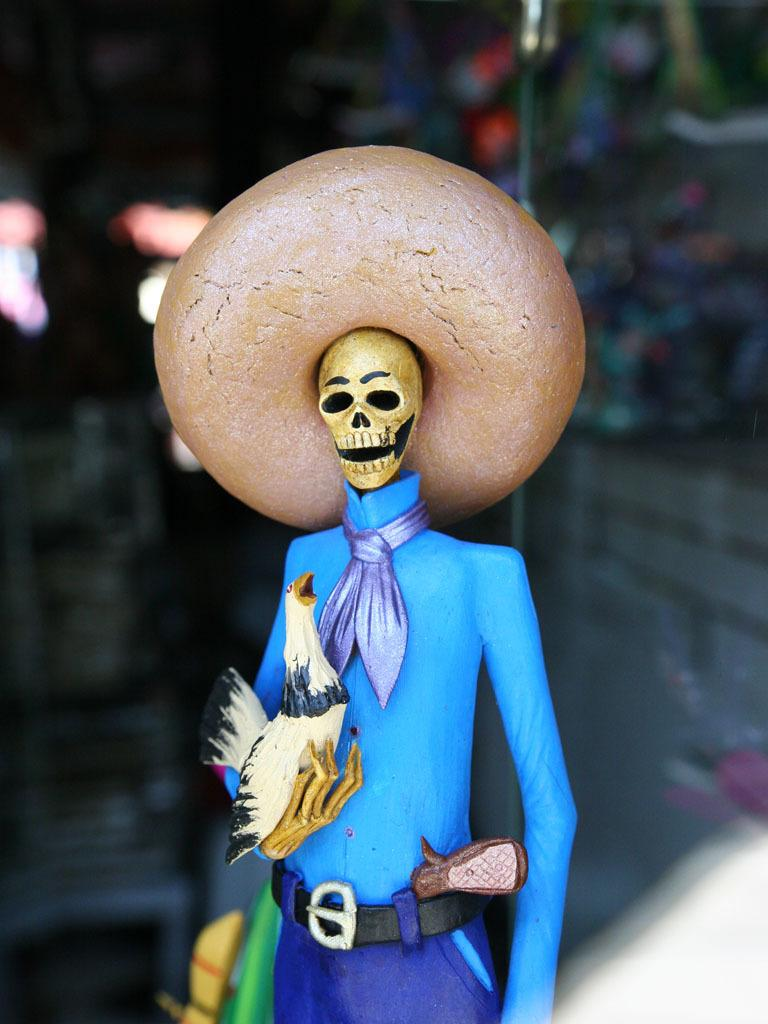What is the main subject in the middle of the image? There is a toy in the middle of the image. Can you describe the background of the image? The background of the image is blurry. How many tickets are visible in the image? There are no tickets present in the image. What type of knowledge is being displayed by the toy in the image? The toy in the image is not displaying any knowledge, as it is an inanimate object. 